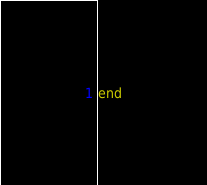<code> <loc_0><loc_0><loc_500><loc_500><_Ruby_>end
</code> 